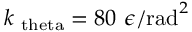Convert formula to latex. <formula><loc_0><loc_0><loc_500><loc_500>k _ { \ t h e t a } = 8 0 \epsilon / r a d ^ { 2 }</formula> 